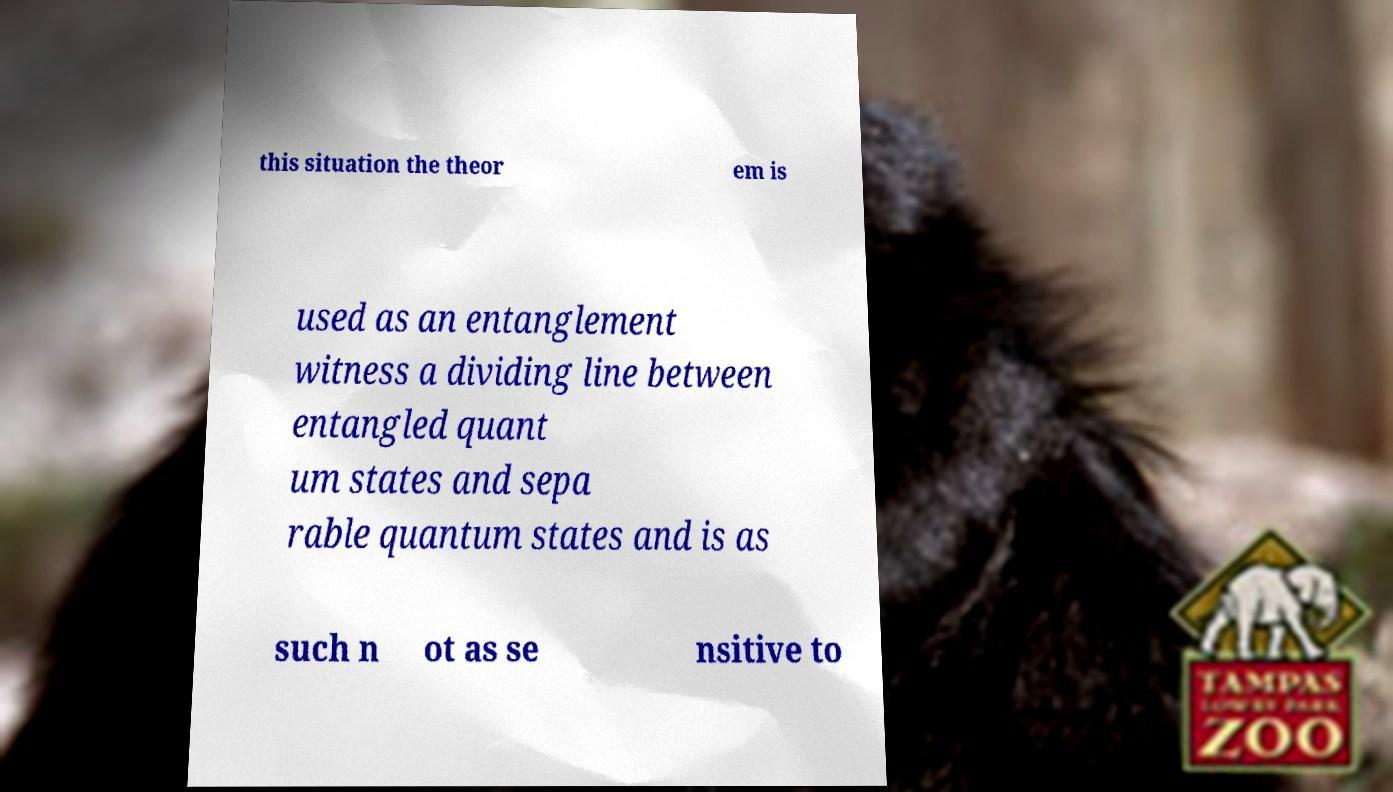Could you extract and type out the text from this image? this situation the theor em is used as an entanglement witness a dividing line between entangled quant um states and sepa rable quantum states and is as such n ot as se nsitive to 